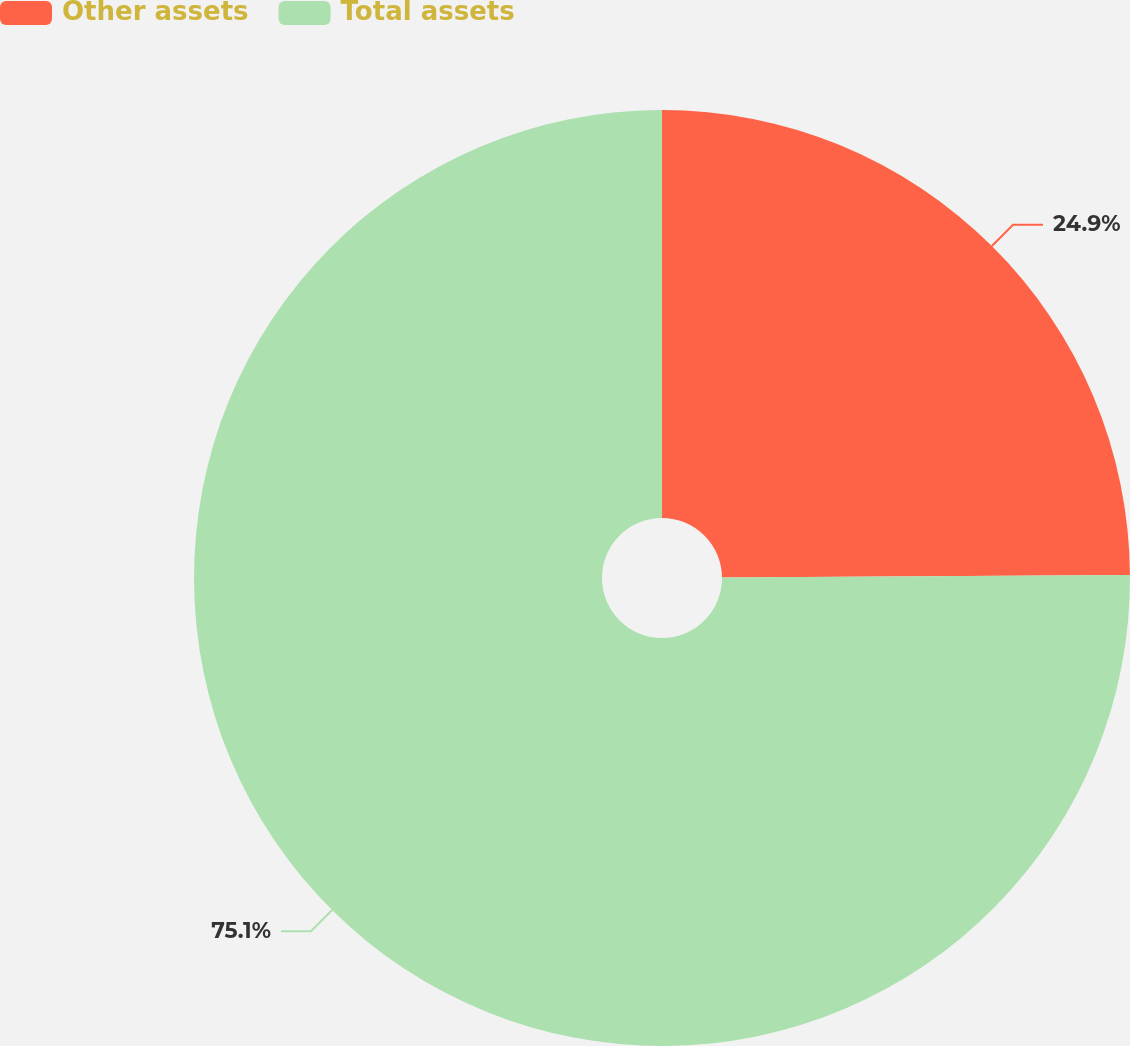Convert chart to OTSL. <chart><loc_0><loc_0><loc_500><loc_500><pie_chart><fcel>Other assets<fcel>Total assets<nl><fcel>24.9%<fcel>75.1%<nl></chart> 